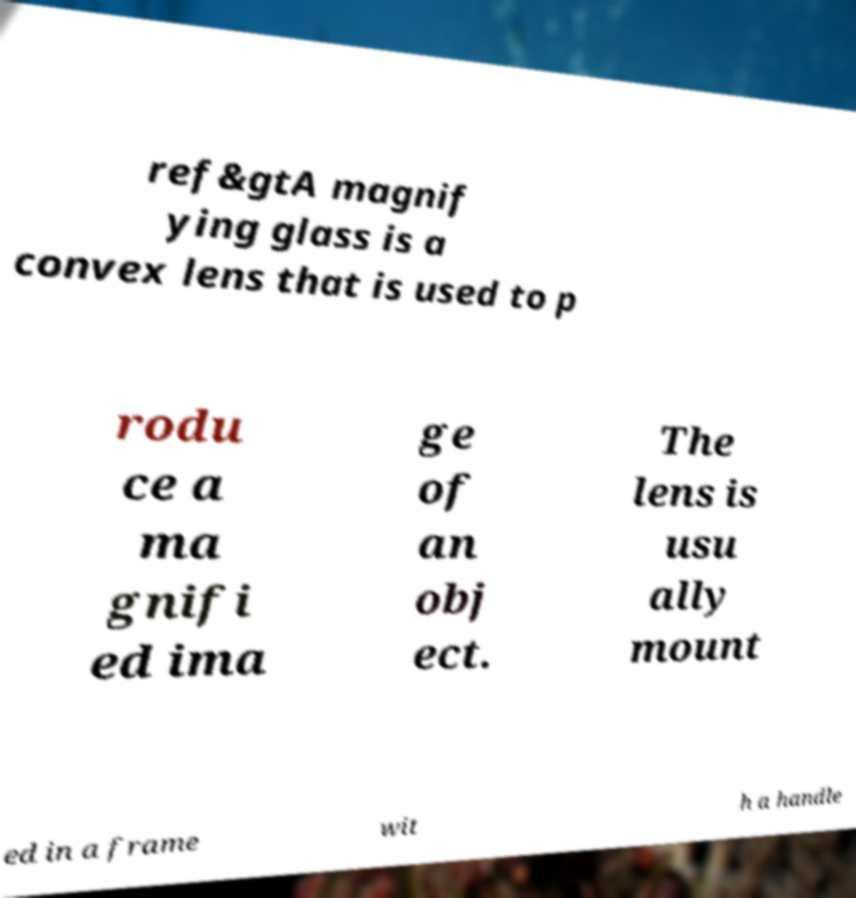There's text embedded in this image that I need extracted. Can you transcribe it verbatim? ref&gtA magnif ying glass is a convex lens that is used to p rodu ce a ma gnifi ed ima ge of an obj ect. The lens is usu ally mount ed in a frame wit h a handle 